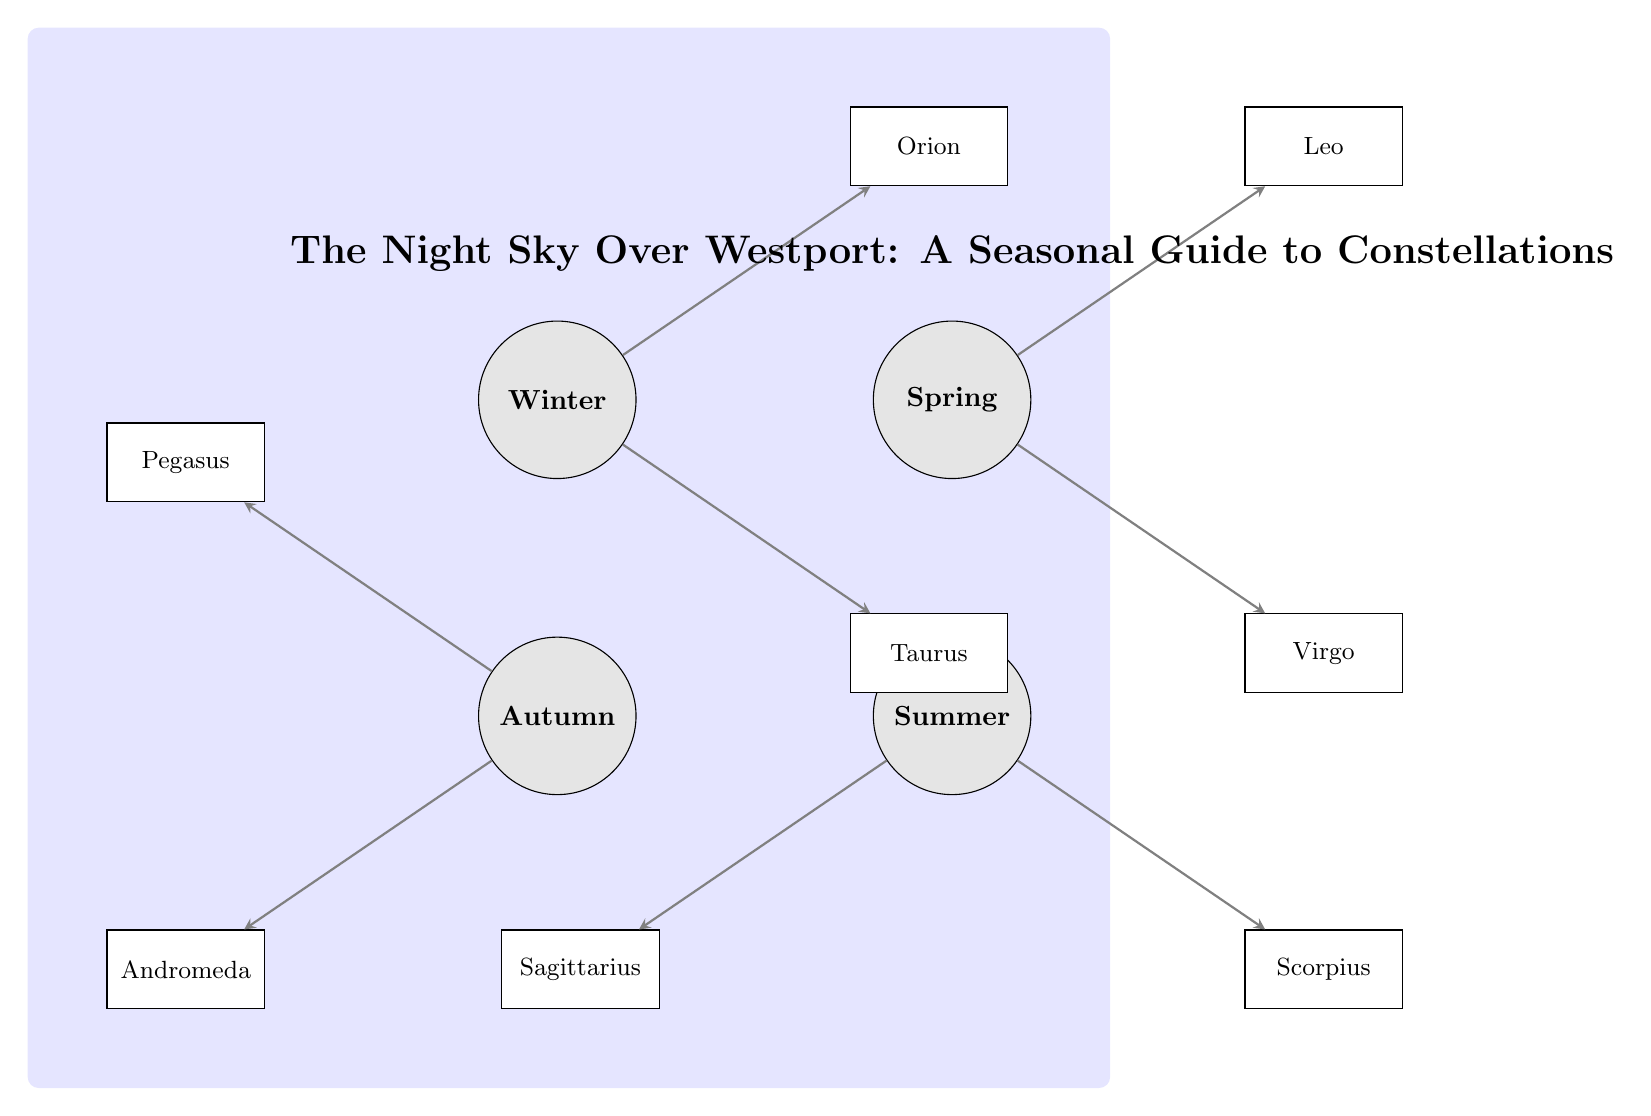What are the winter constellations depicted in the diagram? The diagram shows the constellations associated with winter, which are Orion and Taurus, positioned to the right of the Winter node.
Answer: Orion, Taurus Which season has the constellation Leo? Leo is connected directly to the Spring node in the diagram, indicating it is a constellation visible during that season.
Answer: Spring How many constellations are associated with summer? The diagram illustrates two constellations linked to the Summer node: Scorpius and Sagittarius, hence the total count is two.
Answer: 2 What season is represented directly opposite autumn in the diagram? The Winter season is located directly across from Autumn in the diagram, fulfilling this positional criterion.
Answer: Winter Which two constellations are associated with autumn? The diagram indicates that the constellations Pegasus and Andromeda are associated with the Autumn season, as shown connected to its node.
Answer: Pegasus, Andromeda Which constellations can be observed during spring? The diagram clearly depicts that during spring, the constellations that can be observed are Leo and Virgo, both linked to the Spring node.
Answer: Leo, Virgo What is the relationship between summer and the constellations? The Summer node is directly connected to the constellations Scorpius and Sagittarius, denoting that these are the observable constellations during that season.
Answer: Scorpius, Sagittarius How many total seasons are represented in the diagram? The diagram contains four distinct nodes for each season: Winter, Spring, Summer, and Autumn, leading to a total of four seasons represented.
Answer: 4 Which constellation is positioned above left of the Autumn node? The diagram shows that Pegasus is the constellation positioned above left from the Autumn node, indicating its seasonal association.
Answer: Pegasus 